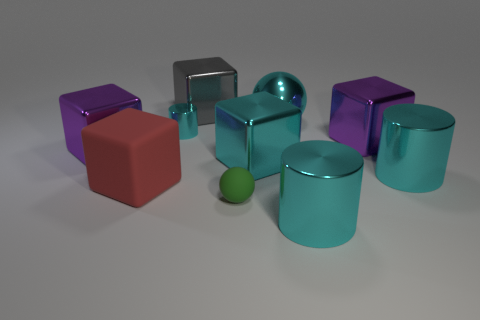There is a matte thing that is the same size as the cyan sphere; what color is it?
Ensure brevity in your answer.  Red. What number of other objects are the same shape as the gray thing?
Offer a very short reply. 4. Is there a small red ball made of the same material as the green sphere?
Offer a terse response. No. Are the cyan thing that is in front of the large red cube and the purple block that is on the right side of the large gray metallic block made of the same material?
Give a very brief answer. Yes. What number of tiny rubber balls are there?
Your answer should be very brief. 1. There is a big red rubber thing to the left of the cyan ball; what is its shape?
Your answer should be very brief. Cube. How many other things are there of the same size as the cyan metallic cube?
Your answer should be very brief. 7. There is a large purple shiny thing to the right of the gray thing; is its shape the same as the tiny thing right of the small cyan metallic cylinder?
Your answer should be very brief. No. What number of large cyan metallic objects are behind the small cylinder?
Make the answer very short. 1. What is the color of the small rubber ball that is in front of the large gray cube?
Provide a short and direct response. Green. 